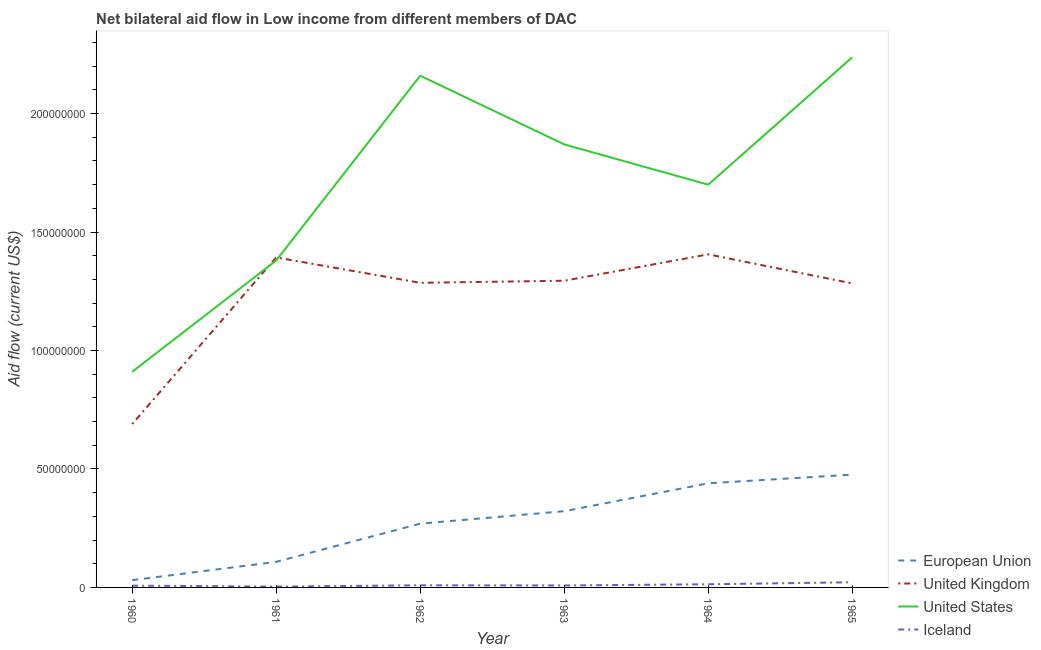What is the amount of aid given by uk in 1963?
Your response must be concise. 1.29e+08. Across all years, what is the maximum amount of aid given by eu?
Make the answer very short. 4.76e+07. Across all years, what is the minimum amount of aid given by uk?
Your answer should be compact. 6.90e+07. In which year was the amount of aid given by iceland maximum?
Your response must be concise. 1965. In which year was the amount of aid given by uk minimum?
Provide a succinct answer. 1960. What is the total amount of aid given by iceland in the graph?
Give a very brief answer. 6.33e+06. What is the difference between the amount of aid given by uk in 1960 and that in 1963?
Keep it short and to the point. -6.05e+07. What is the difference between the amount of aid given by iceland in 1962 and the amount of aid given by us in 1965?
Offer a very short reply. -2.23e+08. What is the average amount of aid given by us per year?
Your response must be concise. 1.71e+08. In the year 1962, what is the difference between the amount of aid given by uk and amount of aid given by iceland?
Your answer should be compact. 1.28e+08. In how many years, is the amount of aid given by uk greater than 30000000 US$?
Keep it short and to the point. 6. What is the ratio of the amount of aid given by us in 1960 to that in 1963?
Provide a succinct answer. 0.49. What is the difference between the highest and the second highest amount of aid given by uk?
Provide a succinct answer. 1.30e+06. What is the difference between the highest and the lowest amount of aid given by us?
Your answer should be compact. 1.33e+08. In how many years, is the amount of aid given by us greater than the average amount of aid given by us taken over all years?
Ensure brevity in your answer.  3. Is the sum of the amount of aid given by us in 1964 and 1965 greater than the maximum amount of aid given by eu across all years?
Provide a succinct answer. Yes. Is it the case that in every year, the sum of the amount of aid given by uk and amount of aid given by iceland is greater than the sum of amount of aid given by us and amount of aid given by eu?
Give a very brief answer. No. Is it the case that in every year, the sum of the amount of aid given by eu and amount of aid given by uk is greater than the amount of aid given by us?
Offer a very short reply. No. Is the amount of aid given by uk strictly less than the amount of aid given by eu over the years?
Your answer should be compact. No. How many lines are there?
Your answer should be very brief. 4. How many years are there in the graph?
Ensure brevity in your answer.  6. Does the graph contain any zero values?
Offer a very short reply. No. Does the graph contain grids?
Provide a short and direct response. No. How are the legend labels stacked?
Your answer should be compact. Vertical. What is the title of the graph?
Give a very brief answer. Net bilateral aid flow in Low income from different members of DAC. Does "Plant species" appear as one of the legend labels in the graph?
Give a very brief answer. No. What is the label or title of the Y-axis?
Offer a terse response. Aid flow (current US$). What is the Aid flow (current US$) of European Union in 1960?
Provide a short and direct response. 3.06e+06. What is the Aid flow (current US$) in United Kingdom in 1960?
Ensure brevity in your answer.  6.90e+07. What is the Aid flow (current US$) of United States in 1960?
Ensure brevity in your answer.  9.10e+07. What is the Aid flow (current US$) in Iceland in 1960?
Provide a short and direct response. 7.50e+05. What is the Aid flow (current US$) in European Union in 1961?
Keep it short and to the point. 1.08e+07. What is the Aid flow (current US$) in United Kingdom in 1961?
Make the answer very short. 1.39e+08. What is the Aid flow (current US$) of United States in 1961?
Your answer should be compact. 1.38e+08. What is the Aid flow (current US$) of Iceland in 1961?
Provide a succinct answer. 3.40e+05. What is the Aid flow (current US$) in European Union in 1962?
Give a very brief answer. 2.69e+07. What is the Aid flow (current US$) of United Kingdom in 1962?
Offer a terse response. 1.29e+08. What is the Aid flow (current US$) of United States in 1962?
Provide a short and direct response. 2.16e+08. What is the Aid flow (current US$) of Iceland in 1962?
Make the answer very short. 9.00e+05. What is the Aid flow (current US$) in European Union in 1963?
Provide a short and direct response. 3.22e+07. What is the Aid flow (current US$) of United Kingdom in 1963?
Ensure brevity in your answer.  1.29e+08. What is the Aid flow (current US$) in United States in 1963?
Offer a terse response. 1.87e+08. What is the Aid flow (current US$) of Iceland in 1963?
Your response must be concise. 8.30e+05. What is the Aid flow (current US$) of European Union in 1964?
Provide a short and direct response. 4.40e+07. What is the Aid flow (current US$) of United Kingdom in 1964?
Make the answer very short. 1.41e+08. What is the Aid flow (current US$) of United States in 1964?
Your answer should be compact. 1.70e+08. What is the Aid flow (current US$) of Iceland in 1964?
Provide a succinct answer. 1.33e+06. What is the Aid flow (current US$) of European Union in 1965?
Provide a succinct answer. 4.76e+07. What is the Aid flow (current US$) of United Kingdom in 1965?
Offer a terse response. 1.28e+08. What is the Aid flow (current US$) of United States in 1965?
Make the answer very short. 2.24e+08. What is the Aid flow (current US$) in Iceland in 1965?
Your answer should be compact. 2.18e+06. Across all years, what is the maximum Aid flow (current US$) in European Union?
Provide a succinct answer. 4.76e+07. Across all years, what is the maximum Aid flow (current US$) of United Kingdom?
Keep it short and to the point. 1.41e+08. Across all years, what is the maximum Aid flow (current US$) in United States?
Ensure brevity in your answer.  2.24e+08. Across all years, what is the maximum Aid flow (current US$) of Iceland?
Provide a succinct answer. 2.18e+06. Across all years, what is the minimum Aid flow (current US$) in European Union?
Offer a very short reply. 3.06e+06. Across all years, what is the minimum Aid flow (current US$) in United Kingdom?
Ensure brevity in your answer.  6.90e+07. Across all years, what is the minimum Aid flow (current US$) in United States?
Provide a succinct answer. 9.10e+07. Across all years, what is the minimum Aid flow (current US$) of Iceland?
Your response must be concise. 3.40e+05. What is the total Aid flow (current US$) in European Union in the graph?
Your answer should be very brief. 1.65e+08. What is the total Aid flow (current US$) of United Kingdom in the graph?
Provide a succinct answer. 7.35e+08. What is the total Aid flow (current US$) of United States in the graph?
Your answer should be very brief. 1.03e+09. What is the total Aid flow (current US$) in Iceland in the graph?
Keep it short and to the point. 6.33e+06. What is the difference between the Aid flow (current US$) of European Union in 1960 and that in 1961?
Provide a short and direct response. -7.74e+06. What is the difference between the Aid flow (current US$) in United Kingdom in 1960 and that in 1961?
Provide a succinct answer. -7.03e+07. What is the difference between the Aid flow (current US$) of United States in 1960 and that in 1961?
Provide a short and direct response. -4.70e+07. What is the difference between the Aid flow (current US$) in Iceland in 1960 and that in 1961?
Your answer should be very brief. 4.10e+05. What is the difference between the Aid flow (current US$) in European Union in 1960 and that in 1962?
Give a very brief answer. -2.39e+07. What is the difference between the Aid flow (current US$) in United Kingdom in 1960 and that in 1962?
Your answer should be very brief. -5.96e+07. What is the difference between the Aid flow (current US$) of United States in 1960 and that in 1962?
Provide a succinct answer. -1.25e+08. What is the difference between the Aid flow (current US$) in Iceland in 1960 and that in 1962?
Make the answer very short. -1.50e+05. What is the difference between the Aid flow (current US$) in European Union in 1960 and that in 1963?
Keep it short and to the point. -2.91e+07. What is the difference between the Aid flow (current US$) of United Kingdom in 1960 and that in 1963?
Offer a very short reply. -6.05e+07. What is the difference between the Aid flow (current US$) of United States in 1960 and that in 1963?
Your answer should be very brief. -9.60e+07. What is the difference between the Aid flow (current US$) in European Union in 1960 and that in 1964?
Provide a succinct answer. -4.09e+07. What is the difference between the Aid flow (current US$) of United Kingdom in 1960 and that in 1964?
Offer a very short reply. -7.16e+07. What is the difference between the Aid flow (current US$) of United States in 1960 and that in 1964?
Ensure brevity in your answer.  -7.90e+07. What is the difference between the Aid flow (current US$) in Iceland in 1960 and that in 1964?
Make the answer very short. -5.80e+05. What is the difference between the Aid flow (current US$) of European Union in 1960 and that in 1965?
Offer a very short reply. -4.46e+07. What is the difference between the Aid flow (current US$) of United Kingdom in 1960 and that in 1965?
Provide a succinct answer. -5.94e+07. What is the difference between the Aid flow (current US$) of United States in 1960 and that in 1965?
Make the answer very short. -1.33e+08. What is the difference between the Aid flow (current US$) in Iceland in 1960 and that in 1965?
Your response must be concise. -1.43e+06. What is the difference between the Aid flow (current US$) in European Union in 1961 and that in 1962?
Your answer should be very brief. -1.61e+07. What is the difference between the Aid flow (current US$) in United Kingdom in 1961 and that in 1962?
Your response must be concise. 1.07e+07. What is the difference between the Aid flow (current US$) of United States in 1961 and that in 1962?
Make the answer very short. -7.80e+07. What is the difference between the Aid flow (current US$) in Iceland in 1961 and that in 1962?
Your answer should be compact. -5.60e+05. What is the difference between the Aid flow (current US$) of European Union in 1961 and that in 1963?
Keep it short and to the point. -2.14e+07. What is the difference between the Aid flow (current US$) of United Kingdom in 1961 and that in 1963?
Offer a very short reply. 9.83e+06. What is the difference between the Aid flow (current US$) of United States in 1961 and that in 1963?
Ensure brevity in your answer.  -4.90e+07. What is the difference between the Aid flow (current US$) of Iceland in 1961 and that in 1963?
Offer a very short reply. -4.90e+05. What is the difference between the Aid flow (current US$) of European Union in 1961 and that in 1964?
Provide a short and direct response. -3.32e+07. What is the difference between the Aid flow (current US$) of United Kingdom in 1961 and that in 1964?
Provide a short and direct response. -1.30e+06. What is the difference between the Aid flow (current US$) in United States in 1961 and that in 1964?
Offer a terse response. -3.20e+07. What is the difference between the Aid flow (current US$) in Iceland in 1961 and that in 1964?
Ensure brevity in your answer.  -9.90e+05. What is the difference between the Aid flow (current US$) of European Union in 1961 and that in 1965?
Your response must be concise. -3.68e+07. What is the difference between the Aid flow (current US$) of United Kingdom in 1961 and that in 1965?
Your response must be concise. 1.10e+07. What is the difference between the Aid flow (current US$) of United States in 1961 and that in 1965?
Provide a succinct answer. -8.58e+07. What is the difference between the Aid flow (current US$) in Iceland in 1961 and that in 1965?
Provide a succinct answer. -1.84e+06. What is the difference between the Aid flow (current US$) of European Union in 1962 and that in 1963?
Offer a terse response. -5.26e+06. What is the difference between the Aid flow (current US$) of United Kingdom in 1962 and that in 1963?
Offer a terse response. -8.80e+05. What is the difference between the Aid flow (current US$) of United States in 1962 and that in 1963?
Make the answer very short. 2.90e+07. What is the difference between the Aid flow (current US$) in European Union in 1962 and that in 1964?
Offer a terse response. -1.70e+07. What is the difference between the Aid flow (current US$) of United Kingdom in 1962 and that in 1964?
Give a very brief answer. -1.20e+07. What is the difference between the Aid flow (current US$) in United States in 1962 and that in 1964?
Make the answer very short. 4.60e+07. What is the difference between the Aid flow (current US$) in Iceland in 1962 and that in 1964?
Offer a very short reply. -4.30e+05. What is the difference between the Aid flow (current US$) in European Union in 1962 and that in 1965?
Keep it short and to the point. -2.07e+07. What is the difference between the Aid flow (current US$) of United Kingdom in 1962 and that in 1965?
Your answer should be very brief. 2.50e+05. What is the difference between the Aid flow (current US$) of United States in 1962 and that in 1965?
Offer a terse response. -7.77e+06. What is the difference between the Aid flow (current US$) in Iceland in 1962 and that in 1965?
Keep it short and to the point. -1.28e+06. What is the difference between the Aid flow (current US$) of European Union in 1963 and that in 1964?
Offer a terse response. -1.18e+07. What is the difference between the Aid flow (current US$) in United Kingdom in 1963 and that in 1964?
Make the answer very short. -1.11e+07. What is the difference between the Aid flow (current US$) in United States in 1963 and that in 1964?
Make the answer very short. 1.70e+07. What is the difference between the Aid flow (current US$) of Iceland in 1963 and that in 1964?
Ensure brevity in your answer.  -5.00e+05. What is the difference between the Aid flow (current US$) in European Union in 1963 and that in 1965?
Provide a succinct answer. -1.54e+07. What is the difference between the Aid flow (current US$) in United Kingdom in 1963 and that in 1965?
Offer a very short reply. 1.13e+06. What is the difference between the Aid flow (current US$) in United States in 1963 and that in 1965?
Offer a terse response. -3.68e+07. What is the difference between the Aid flow (current US$) in Iceland in 1963 and that in 1965?
Ensure brevity in your answer.  -1.35e+06. What is the difference between the Aid flow (current US$) in European Union in 1964 and that in 1965?
Ensure brevity in your answer.  -3.66e+06. What is the difference between the Aid flow (current US$) in United Kingdom in 1964 and that in 1965?
Keep it short and to the point. 1.23e+07. What is the difference between the Aid flow (current US$) in United States in 1964 and that in 1965?
Provide a succinct answer. -5.38e+07. What is the difference between the Aid flow (current US$) of Iceland in 1964 and that in 1965?
Offer a very short reply. -8.50e+05. What is the difference between the Aid flow (current US$) in European Union in 1960 and the Aid flow (current US$) in United Kingdom in 1961?
Ensure brevity in your answer.  -1.36e+08. What is the difference between the Aid flow (current US$) of European Union in 1960 and the Aid flow (current US$) of United States in 1961?
Your answer should be very brief. -1.35e+08. What is the difference between the Aid flow (current US$) in European Union in 1960 and the Aid flow (current US$) in Iceland in 1961?
Make the answer very short. 2.72e+06. What is the difference between the Aid flow (current US$) in United Kingdom in 1960 and the Aid flow (current US$) in United States in 1961?
Offer a very short reply. -6.90e+07. What is the difference between the Aid flow (current US$) of United Kingdom in 1960 and the Aid flow (current US$) of Iceland in 1961?
Ensure brevity in your answer.  6.86e+07. What is the difference between the Aid flow (current US$) of United States in 1960 and the Aid flow (current US$) of Iceland in 1961?
Ensure brevity in your answer.  9.07e+07. What is the difference between the Aid flow (current US$) in European Union in 1960 and the Aid flow (current US$) in United Kingdom in 1962?
Keep it short and to the point. -1.26e+08. What is the difference between the Aid flow (current US$) in European Union in 1960 and the Aid flow (current US$) in United States in 1962?
Keep it short and to the point. -2.13e+08. What is the difference between the Aid flow (current US$) of European Union in 1960 and the Aid flow (current US$) of Iceland in 1962?
Give a very brief answer. 2.16e+06. What is the difference between the Aid flow (current US$) in United Kingdom in 1960 and the Aid flow (current US$) in United States in 1962?
Your response must be concise. -1.47e+08. What is the difference between the Aid flow (current US$) in United Kingdom in 1960 and the Aid flow (current US$) in Iceland in 1962?
Your answer should be compact. 6.80e+07. What is the difference between the Aid flow (current US$) in United States in 1960 and the Aid flow (current US$) in Iceland in 1962?
Your answer should be compact. 9.01e+07. What is the difference between the Aid flow (current US$) of European Union in 1960 and the Aid flow (current US$) of United Kingdom in 1963?
Offer a very short reply. -1.26e+08. What is the difference between the Aid flow (current US$) of European Union in 1960 and the Aid flow (current US$) of United States in 1963?
Provide a succinct answer. -1.84e+08. What is the difference between the Aid flow (current US$) in European Union in 1960 and the Aid flow (current US$) in Iceland in 1963?
Offer a terse response. 2.23e+06. What is the difference between the Aid flow (current US$) of United Kingdom in 1960 and the Aid flow (current US$) of United States in 1963?
Keep it short and to the point. -1.18e+08. What is the difference between the Aid flow (current US$) of United Kingdom in 1960 and the Aid flow (current US$) of Iceland in 1963?
Offer a very short reply. 6.81e+07. What is the difference between the Aid flow (current US$) in United States in 1960 and the Aid flow (current US$) in Iceland in 1963?
Keep it short and to the point. 9.02e+07. What is the difference between the Aid flow (current US$) in European Union in 1960 and the Aid flow (current US$) in United Kingdom in 1964?
Your answer should be very brief. -1.38e+08. What is the difference between the Aid flow (current US$) of European Union in 1960 and the Aid flow (current US$) of United States in 1964?
Give a very brief answer. -1.67e+08. What is the difference between the Aid flow (current US$) in European Union in 1960 and the Aid flow (current US$) in Iceland in 1964?
Your answer should be very brief. 1.73e+06. What is the difference between the Aid flow (current US$) in United Kingdom in 1960 and the Aid flow (current US$) in United States in 1964?
Your answer should be compact. -1.01e+08. What is the difference between the Aid flow (current US$) of United Kingdom in 1960 and the Aid flow (current US$) of Iceland in 1964?
Give a very brief answer. 6.76e+07. What is the difference between the Aid flow (current US$) in United States in 1960 and the Aid flow (current US$) in Iceland in 1964?
Give a very brief answer. 8.97e+07. What is the difference between the Aid flow (current US$) of European Union in 1960 and the Aid flow (current US$) of United Kingdom in 1965?
Offer a very short reply. -1.25e+08. What is the difference between the Aid flow (current US$) in European Union in 1960 and the Aid flow (current US$) in United States in 1965?
Your answer should be very brief. -2.21e+08. What is the difference between the Aid flow (current US$) in European Union in 1960 and the Aid flow (current US$) in Iceland in 1965?
Your answer should be very brief. 8.80e+05. What is the difference between the Aid flow (current US$) of United Kingdom in 1960 and the Aid flow (current US$) of United States in 1965?
Make the answer very short. -1.55e+08. What is the difference between the Aid flow (current US$) of United Kingdom in 1960 and the Aid flow (current US$) of Iceland in 1965?
Offer a very short reply. 6.68e+07. What is the difference between the Aid flow (current US$) in United States in 1960 and the Aid flow (current US$) in Iceland in 1965?
Ensure brevity in your answer.  8.88e+07. What is the difference between the Aid flow (current US$) in European Union in 1961 and the Aid flow (current US$) in United Kingdom in 1962?
Make the answer very short. -1.18e+08. What is the difference between the Aid flow (current US$) in European Union in 1961 and the Aid flow (current US$) in United States in 1962?
Offer a terse response. -2.05e+08. What is the difference between the Aid flow (current US$) in European Union in 1961 and the Aid flow (current US$) in Iceland in 1962?
Your response must be concise. 9.90e+06. What is the difference between the Aid flow (current US$) in United Kingdom in 1961 and the Aid flow (current US$) in United States in 1962?
Offer a terse response. -7.67e+07. What is the difference between the Aid flow (current US$) in United Kingdom in 1961 and the Aid flow (current US$) in Iceland in 1962?
Provide a short and direct response. 1.38e+08. What is the difference between the Aid flow (current US$) in United States in 1961 and the Aid flow (current US$) in Iceland in 1962?
Your answer should be compact. 1.37e+08. What is the difference between the Aid flow (current US$) in European Union in 1961 and the Aid flow (current US$) in United Kingdom in 1963?
Make the answer very short. -1.19e+08. What is the difference between the Aid flow (current US$) of European Union in 1961 and the Aid flow (current US$) of United States in 1963?
Make the answer very short. -1.76e+08. What is the difference between the Aid flow (current US$) in European Union in 1961 and the Aid flow (current US$) in Iceland in 1963?
Provide a short and direct response. 9.97e+06. What is the difference between the Aid flow (current US$) in United Kingdom in 1961 and the Aid flow (current US$) in United States in 1963?
Give a very brief answer. -4.77e+07. What is the difference between the Aid flow (current US$) of United Kingdom in 1961 and the Aid flow (current US$) of Iceland in 1963?
Provide a succinct answer. 1.38e+08. What is the difference between the Aid flow (current US$) in United States in 1961 and the Aid flow (current US$) in Iceland in 1963?
Keep it short and to the point. 1.37e+08. What is the difference between the Aid flow (current US$) in European Union in 1961 and the Aid flow (current US$) in United Kingdom in 1964?
Ensure brevity in your answer.  -1.30e+08. What is the difference between the Aid flow (current US$) in European Union in 1961 and the Aid flow (current US$) in United States in 1964?
Give a very brief answer. -1.59e+08. What is the difference between the Aid flow (current US$) of European Union in 1961 and the Aid flow (current US$) of Iceland in 1964?
Keep it short and to the point. 9.47e+06. What is the difference between the Aid flow (current US$) in United Kingdom in 1961 and the Aid flow (current US$) in United States in 1964?
Your response must be concise. -3.07e+07. What is the difference between the Aid flow (current US$) in United Kingdom in 1961 and the Aid flow (current US$) in Iceland in 1964?
Make the answer very short. 1.38e+08. What is the difference between the Aid flow (current US$) of United States in 1961 and the Aid flow (current US$) of Iceland in 1964?
Give a very brief answer. 1.37e+08. What is the difference between the Aid flow (current US$) of European Union in 1961 and the Aid flow (current US$) of United Kingdom in 1965?
Offer a terse response. -1.18e+08. What is the difference between the Aid flow (current US$) in European Union in 1961 and the Aid flow (current US$) in United States in 1965?
Offer a terse response. -2.13e+08. What is the difference between the Aid flow (current US$) of European Union in 1961 and the Aid flow (current US$) of Iceland in 1965?
Offer a very short reply. 8.62e+06. What is the difference between the Aid flow (current US$) of United Kingdom in 1961 and the Aid flow (current US$) of United States in 1965?
Your answer should be compact. -8.45e+07. What is the difference between the Aid flow (current US$) of United Kingdom in 1961 and the Aid flow (current US$) of Iceland in 1965?
Your response must be concise. 1.37e+08. What is the difference between the Aid flow (current US$) in United States in 1961 and the Aid flow (current US$) in Iceland in 1965?
Make the answer very short. 1.36e+08. What is the difference between the Aid flow (current US$) of European Union in 1962 and the Aid flow (current US$) of United Kingdom in 1963?
Provide a succinct answer. -1.03e+08. What is the difference between the Aid flow (current US$) in European Union in 1962 and the Aid flow (current US$) in United States in 1963?
Make the answer very short. -1.60e+08. What is the difference between the Aid flow (current US$) of European Union in 1962 and the Aid flow (current US$) of Iceland in 1963?
Give a very brief answer. 2.61e+07. What is the difference between the Aid flow (current US$) in United Kingdom in 1962 and the Aid flow (current US$) in United States in 1963?
Keep it short and to the point. -5.84e+07. What is the difference between the Aid flow (current US$) in United Kingdom in 1962 and the Aid flow (current US$) in Iceland in 1963?
Make the answer very short. 1.28e+08. What is the difference between the Aid flow (current US$) of United States in 1962 and the Aid flow (current US$) of Iceland in 1963?
Your answer should be very brief. 2.15e+08. What is the difference between the Aid flow (current US$) in European Union in 1962 and the Aid flow (current US$) in United Kingdom in 1964?
Your answer should be very brief. -1.14e+08. What is the difference between the Aid flow (current US$) in European Union in 1962 and the Aid flow (current US$) in United States in 1964?
Offer a terse response. -1.43e+08. What is the difference between the Aid flow (current US$) of European Union in 1962 and the Aid flow (current US$) of Iceland in 1964?
Provide a succinct answer. 2.56e+07. What is the difference between the Aid flow (current US$) in United Kingdom in 1962 and the Aid flow (current US$) in United States in 1964?
Provide a succinct answer. -4.14e+07. What is the difference between the Aid flow (current US$) in United Kingdom in 1962 and the Aid flow (current US$) in Iceland in 1964?
Provide a succinct answer. 1.27e+08. What is the difference between the Aid flow (current US$) of United States in 1962 and the Aid flow (current US$) of Iceland in 1964?
Your answer should be compact. 2.15e+08. What is the difference between the Aid flow (current US$) of European Union in 1962 and the Aid flow (current US$) of United Kingdom in 1965?
Your response must be concise. -1.01e+08. What is the difference between the Aid flow (current US$) in European Union in 1962 and the Aid flow (current US$) in United States in 1965?
Ensure brevity in your answer.  -1.97e+08. What is the difference between the Aid flow (current US$) of European Union in 1962 and the Aid flow (current US$) of Iceland in 1965?
Your answer should be compact. 2.47e+07. What is the difference between the Aid flow (current US$) of United Kingdom in 1962 and the Aid flow (current US$) of United States in 1965?
Your answer should be compact. -9.52e+07. What is the difference between the Aid flow (current US$) of United Kingdom in 1962 and the Aid flow (current US$) of Iceland in 1965?
Your response must be concise. 1.26e+08. What is the difference between the Aid flow (current US$) of United States in 1962 and the Aid flow (current US$) of Iceland in 1965?
Keep it short and to the point. 2.14e+08. What is the difference between the Aid flow (current US$) in European Union in 1963 and the Aid flow (current US$) in United Kingdom in 1964?
Make the answer very short. -1.08e+08. What is the difference between the Aid flow (current US$) of European Union in 1963 and the Aid flow (current US$) of United States in 1964?
Make the answer very short. -1.38e+08. What is the difference between the Aid flow (current US$) in European Union in 1963 and the Aid flow (current US$) in Iceland in 1964?
Your answer should be very brief. 3.08e+07. What is the difference between the Aid flow (current US$) in United Kingdom in 1963 and the Aid flow (current US$) in United States in 1964?
Provide a short and direct response. -4.05e+07. What is the difference between the Aid flow (current US$) in United Kingdom in 1963 and the Aid flow (current US$) in Iceland in 1964?
Provide a succinct answer. 1.28e+08. What is the difference between the Aid flow (current US$) of United States in 1963 and the Aid flow (current US$) of Iceland in 1964?
Ensure brevity in your answer.  1.86e+08. What is the difference between the Aid flow (current US$) of European Union in 1963 and the Aid flow (current US$) of United Kingdom in 1965?
Your answer should be compact. -9.62e+07. What is the difference between the Aid flow (current US$) in European Union in 1963 and the Aid flow (current US$) in United States in 1965?
Your answer should be very brief. -1.92e+08. What is the difference between the Aid flow (current US$) of European Union in 1963 and the Aid flow (current US$) of Iceland in 1965?
Give a very brief answer. 3.00e+07. What is the difference between the Aid flow (current US$) of United Kingdom in 1963 and the Aid flow (current US$) of United States in 1965?
Your response must be concise. -9.43e+07. What is the difference between the Aid flow (current US$) in United Kingdom in 1963 and the Aid flow (current US$) in Iceland in 1965?
Offer a terse response. 1.27e+08. What is the difference between the Aid flow (current US$) of United States in 1963 and the Aid flow (current US$) of Iceland in 1965?
Make the answer very short. 1.85e+08. What is the difference between the Aid flow (current US$) of European Union in 1964 and the Aid flow (current US$) of United Kingdom in 1965?
Offer a terse response. -8.44e+07. What is the difference between the Aid flow (current US$) of European Union in 1964 and the Aid flow (current US$) of United States in 1965?
Give a very brief answer. -1.80e+08. What is the difference between the Aid flow (current US$) in European Union in 1964 and the Aid flow (current US$) in Iceland in 1965?
Ensure brevity in your answer.  4.18e+07. What is the difference between the Aid flow (current US$) in United Kingdom in 1964 and the Aid flow (current US$) in United States in 1965?
Provide a succinct answer. -8.32e+07. What is the difference between the Aid flow (current US$) of United Kingdom in 1964 and the Aid flow (current US$) of Iceland in 1965?
Make the answer very short. 1.38e+08. What is the difference between the Aid flow (current US$) in United States in 1964 and the Aid flow (current US$) in Iceland in 1965?
Provide a short and direct response. 1.68e+08. What is the average Aid flow (current US$) in European Union per year?
Make the answer very short. 2.74e+07. What is the average Aid flow (current US$) in United Kingdom per year?
Make the answer very short. 1.23e+08. What is the average Aid flow (current US$) in United States per year?
Provide a short and direct response. 1.71e+08. What is the average Aid flow (current US$) of Iceland per year?
Your answer should be very brief. 1.06e+06. In the year 1960, what is the difference between the Aid flow (current US$) of European Union and Aid flow (current US$) of United Kingdom?
Keep it short and to the point. -6.59e+07. In the year 1960, what is the difference between the Aid flow (current US$) of European Union and Aid flow (current US$) of United States?
Ensure brevity in your answer.  -8.79e+07. In the year 1960, what is the difference between the Aid flow (current US$) of European Union and Aid flow (current US$) of Iceland?
Ensure brevity in your answer.  2.31e+06. In the year 1960, what is the difference between the Aid flow (current US$) of United Kingdom and Aid flow (current US$) of United States?
Provide a succinct answer. -2.20e+07. In the year 1960, what is the difference between the Aid flow (current US$) of United Kingdom and Aid flow (current US$) of Iceland?
Offer a terse response. 6.82e+07. In the year 1960, what is the difference between the Aid flow (current US$) in United States and Aid flow (current US$) in Iceland?
Offer a very short reply. 9.02e+07. In the year 1961, what is the difference between the Aid flow (current US$) of European Union and Aid flow (current US$) of United Kingdom?
Give a very brief answer. -1.28e+08. In the year 1961, what is the difference between the Aid flow (current US$) of European Union and Aid flow (current US$) of United States?
Give a very brief answer. -1.27e+08. In the year 1961, what is the difference between the Aid flow (current US$) in European Union and Aid flow (current US$) in Iceland?
Your answer should be very brief. 1.05e+07. In the year 1961, what is the difference between the Aid flow (current US$) of United Kingdom and Aid flow (current US$) of United States?
Provide a succinct answer. 1.29e+06. In the year 1961, what is the difference between the Aid flow (current US$) of United Kingdom and Aid flow (current US$) of Iceland?
Give a very brief answer. 1.39e+08. In the year 1961, what is the difference between the Aid flow (current US$) of United States and Aid flow (current US$) of Iceland?
Your response must be concise. 1.38e+08. In the year 1962, what is the difference between the Aid flow (current US$) in European Union and Aid flow (current US$) in United Kingdom?
Give a very brief answer. -1.02e+08. In the year 1962, what is the difference between the Aid flow (current US$) of European Union and Aid flow (current US$) of United States?
Your response must be concise. -1.89e+08. In the year 1962, what is the difference between the Aid flow (current US$) in European Union and Aid flow (current US$) in Iceland?
Make the answer very short. 2.60e+07. In the year 1962, what is the difference between the Aid flow (current US$) in United Kingdom and Aid flow (current US$) in United States?
Provide a succinct answer. -8.74e+07. In the year 1962, what is the difference between the Aid flow (current US$) in United Kingdom and Aid flow (current US$) in Iceland?
Your answer should be compact. 1.28e+08. In the year 1962, what is the difference between the Aid flow (current US$) of United States and Aid flow (current US$) of Iceland?
Your answer should be compact. 2.15e+08. In the year 1963, what is the difference between the Aid flow (current US$) of European Union and Aid flow (current US$) of United Kingdom?
Provide a short and direct response. -9.73e+07. In the year 1963, what is the difference between the Aid flow (current US$) of European Union and Aid flow (current US$) of United States?
Offer a terse response. -1.55e+08. In the year 1963, what is the difference between the Aid flow (current US$) of European Union and Aid flow (current US$) of Iceland?
Provide a succinct answer. 3.14e+07. In the year 1963, what is the difference between the Aid flow (current US$) of United Kingdom and Aid flow (current US$) of United States?
Your answer should be compact. -5.75e+07. In the year 1963, what is the difference between the Aid flow (current US$) of United Kingdom and Aid flow (current US$) of Iceland?
Offer a terse response. 1.29e+08. In the year 1963, what is the difference between the Aid flow (current US$) in United States and Aid flow (current US$) in Iceland?
Offer a terse response. 1.86e+08. In the year 1964, what is the difference between the Aid flow (current US$) in European Union and Aid flow (current US$) in United Kingdom?
Provide a short and direct response. -9.66e+07. In the year 1964, what is the difference between the Aid flow (current US$) in European Union and Aid flow (current US$) in United States?
Your response must be concise. -1.26e+08. In the year 1964, what is the difference between the Aid flow (current US$) in European Union and Aid flow (current US$) in Iceland?
Offer a very short reply. 4.26e+07. In the year 1964, what is the difference between the Aid flow (current US$) in United Kingdom and Aid flow (current US$) in United States?
Your answer should be very brief. -2.94e+07. In the year 1964, what is the difference between the Aid flow (current US$) in United Kingdom and Aid flow (current US$) in Iceland?
Provide a succinct answer. 1.39e+08. In the year 1964, what is the difference between the Aid flow (current US$) in United States and Aid flow (current US$) in Iceland?
Your answer should be very brief. 1.69e+08. In the year 1965, what is the difference between the Aid flow (current US$) in European Union and Aid flow (current US$) in United Kingdom?
Provide a short and direct response. -8.07e+07. In the year 1965, what is the difference between the Aid flow (current US$) in European Union and Aid flow (current US$) in United States?
Ensure brevity in your answer.  -1.76e+08. In the year 1965, what is the difference between the Aid flow (current US$) in European Union and Aid flow (current US$) in Iceland?
Keep it short and to the point. 4.54e+07. In the year 1965, what is the difference between the Aid flow (current US$) in United Kingdom and Aid flow (current US$) in United States?
Your answer should be very brief. -9.54e+07. In the year 1965, what is the difference between the Aid flow (current US$) of United Kingdom and Aid flow (current US$) of Iceland?
Ensure brevity in your answer.  1.26e+08. In the year 1965, what is the difference between the Aid flow (current US$) of United States and Aid flow (current US$) of Iceland?
Make the answer very short. 2.22e+08. What is the ratio of the Aid flow (current US$) of European Union in 1960 to that in 1961?
Your response must be concise. 0.28. What is the ratio of the Aid flow (current US$) of United Kingdom in 1960 to that in 1961?
Offer a very short reply. 0.49. What is the ratio of the Aid flow (current US$) in United States in 1960 to that in 1961?
Your answer should be compact. 0.66. What is the ratio of the Aid flow (current US$) in Iceland in 1960 to that in 1961?
Ensure brevity in your answer.  2.21. What is the ratio of the Aid flow (current US$) in European Union in 1960 to that in 1962?
Ensure brevity in your answer.  0.11. What is the ratio of the Aid flow (current US$) in United Kingdom in 1960 to that in 1962?
Offer a very short reply. 0.54. What is the ratio of the Aid flow (current US$) in United States in 1960 to that in 1962?
Your answer should be compact. 0.42. What is the ratio of the Aid flow (current US$) in Iceland in 1960 to that in 1962?
Provide a succinct answer. 0.83. What is the ratio of the Aid flow (current US$) in European Union in 1960 to that in 1963?
Offer a terse response. 0.1. What is the ratio of the Aid flow (current US$) in United Kingdom in 1960 to that in 1963?
Offer a very short reply. 0.53. What is the ratio of the Aid flow (current US$) of United States in 1960 to that in 1963?
Offer a terse response. 0.49. What is the ratio of the Aid flow (current US$) in Iceland in 1960 to that in 1963?
Ensure brevity in your answer.  0.9. What is the ratio of the Aid flow (current US$) of European Union in 1960 to that in 1964?
Keep it short and to the point. 0.07. What is the ratio of the Aid flow (current US$) of United Kingdom in 1960 to that in 1964?
Your answer should be very brief. 0.49. What is the ratio of the Aid flow (current US$) of United States in 1960 to that in 1964?
Your response must be concise. 0.54. What is the ratio of the Aid flow (current US$) in Iceland in 1960 to that in 1964?
Your answer should be compact. 0.56. What is the ratio of the Aid flow (current US$) in European Union in 1960 to that in 1965?
Your answer should be compact. 0.06. What is the ratio of the Aid flow (current US$) in United Kingdom in 1960 to that in 1965?
Ensure brevity in your answer.  0.54. What is the ratio of the Aid flow (current US$) of United States in 1960 to that in 1965?
Your answer should be compact. 0.41. What is the ratio of the Aid flow (current US$) in Iceland in 1960 to that in 1965?
Offer a terse response. 0.34. What is the ratio of the Aid flow (current US$) of European Union in 1961 to that in 1962?
Offer a terse response. 0.4. What is the ratio of the Aid flow (current US$) of United States in 1961 to that in 1962?
Your response must be concise. 0.64. What is the ratio of the Aid flow (current US$) in Iceland in 1961 to that in 1962?
Your response must be concise. 0.38. What is the ratio of the Aid flow (current US$) in European Union in 1961 to that in 1963?
Give a very brief answer. 0.34. What is the ratio of the Aid flow (current US$) of United Kingdom in 1961 to that in 1963?
Provide a succinct answer. 1.08. What is the ratio of the Aid flow (current US$) in United States in 1961 to that in 1963?
Your answer should be very brief. 0.74. What is the ratio of the Aid flow (current US$) of Iceland in 1961 to that in 1963?
Your answer should be very brief. 0.41. What is the ratio of the Aid flow (current US$) of European Union in 1961 to that in 1964?
Your answer should be very brief. 0.25. What is the ratio of the Aid flow (current US$) of United States in 1961 to that in 1964?
Make the answer very short. 0.81. What is the ratio of the Aid flow (current US$) in Iceland in 1961 to that in 1964?
Make the answer very short. 0.26. What is the ratio of the Aid flow (current US$) of European Union in 1961 to that in 1965?
Keep it short and to the point. 0.23. What is the ratio of the Aid flow (current US$) in United Kingdom in 1961 to that in 1965?
Provide a succinct answer. 1.09. What is the ratio of the Aid flow (current US$) of United States in 1961 to that in 1965?
Your answer should be very brief. 0.62. What is the ratio of the Aid flow (current US$) in Iceland in 1961 to that in 1965?
Give a very brief answer. 0.16. What is the ratio of the Aid flow (current US$) in European Union in 1962 to that in 1963?
Ensure brevity in your answer.  0.84. What is the ratio of the Aid flow (current US$) in United States in 1962 to that in 1963?
Give a very brief answer. 1.16. What is the ratio of the Aid flow (current US$) of Iceland in 1962 to that in 1963?
Provide a succinct answer. 1.08. What is the ratio of the Aid flow (current US$) in European Union in 1962 to that in 1964?
Offer a very short reply. 0.61. What is the ratio of the Aid flow (current US$) of United Kingdom in 1962 to that in 1964?
Keep it short and to the point. 0.91. What is the ratio of the Aid flow (current US$) in United States in 1962 to that in 1964?
Your response must be concise. 1.27. What is the ratio of the Aid flow (current US$) of Iceland in 1962 to that in 1964?
Provide a short and direct response. 0.68. What is the ratio of the Aid flow (current US$) of European Union in 1962 to that in 1965?
Your answer should be very brief. 0.57. What is the ratio of the Aid flow (current US$) in United States in 1962 to that in 1965?
Your answer should be very brief. 0.97. What is the ratio of the Aid flow (current US$) of Iceland in 1962 to that in 1965?
Provide a short and direct response. 0.41. What is the ratio of the Aid flow (current US$) of European Union in 1963 to that in 1964?
Offer a terse response. 0.73. What is the ratio of the Aid flow (current US$) of United Kingdom in 1963 to that in 1964?
Your response must be concise. 0.92. What is the ratio of the Aid flow (current US$) of Iceland in 1963 to that in 1964?
Give a very brief answer. 0.62. What is the ratio of the Aid flow (current US$) of European Union in 1963 to that in 1965?
Give a very brief answer. 0.68. What is the ratio of the Aid flow (current US$) of United Kingdom in 1963 to that in 1965?
Provide a succinct answer. 1.01. What is the ratio of the Aid flow (current US$) of United States in 1963 to that in 1965?
Your response must be concise. 0.84. What is the ratio of the Aid flow (current US$) of Iceland in 1963 to that in 1965?
Your answer should be very brief. 0.38. What is the ratio of the Aid flow (current US$) of European Union in 1964 to that in 1965?
Your answer should be very brief. 0.92. What is the ratio of the Aid flow (current US$) of United Kingdom in 1964 to that in 1965?
Give a very brief answer. 1.1. What is the ratio of the Aid flow (current US$) of United States in 1964 to that in 1965?
Provide a succinct answer. 0.76. What is the ratio of the Aid flow (current US$) of Iceland in 1964 to that in 1965?
Make the answer very short. 0.61. What is the difference between the highest and the second highest Aid flow (current US$) of European Union?
Keep it short and to the point. 3.66e+06. What is the difference between the highest and the second highest Aid flow (current US$) in United Kingdom?
Give a very brief answer. 1.30e+06. What is the difference between the highest and the second highest Aid flow (current US$) in United States?
Your response must be concise. 7.77e+06. What is the difference between the highest and the second highest Aid flow (current US$) in Iceland?
Ensure brevity in your answer.  8.50e+05. What is the difference between the highest and the lowest Aid flow (current US$) of European Union?
Provide a succinct answer. 4.46e+07. What is the difference between the highest and the lowest Aid flow (current US$) in United Kingdom?
Offer a very short reply. 7.16e+07. What is the difference between the highest and the lowest Aid flow (current US$) of United States?
Your answer should be compact. 1.33e+08. What is the difference between the highest and the lowest Aid flow (current US$) of Iceland?
Offer a very short reply. 1.84e+06. 